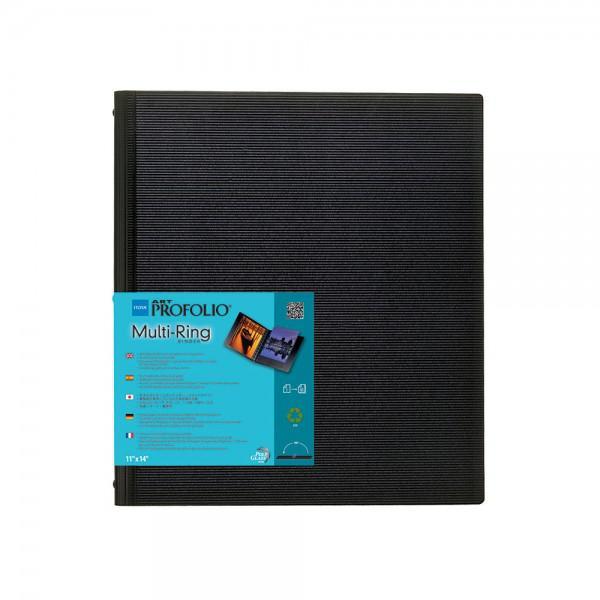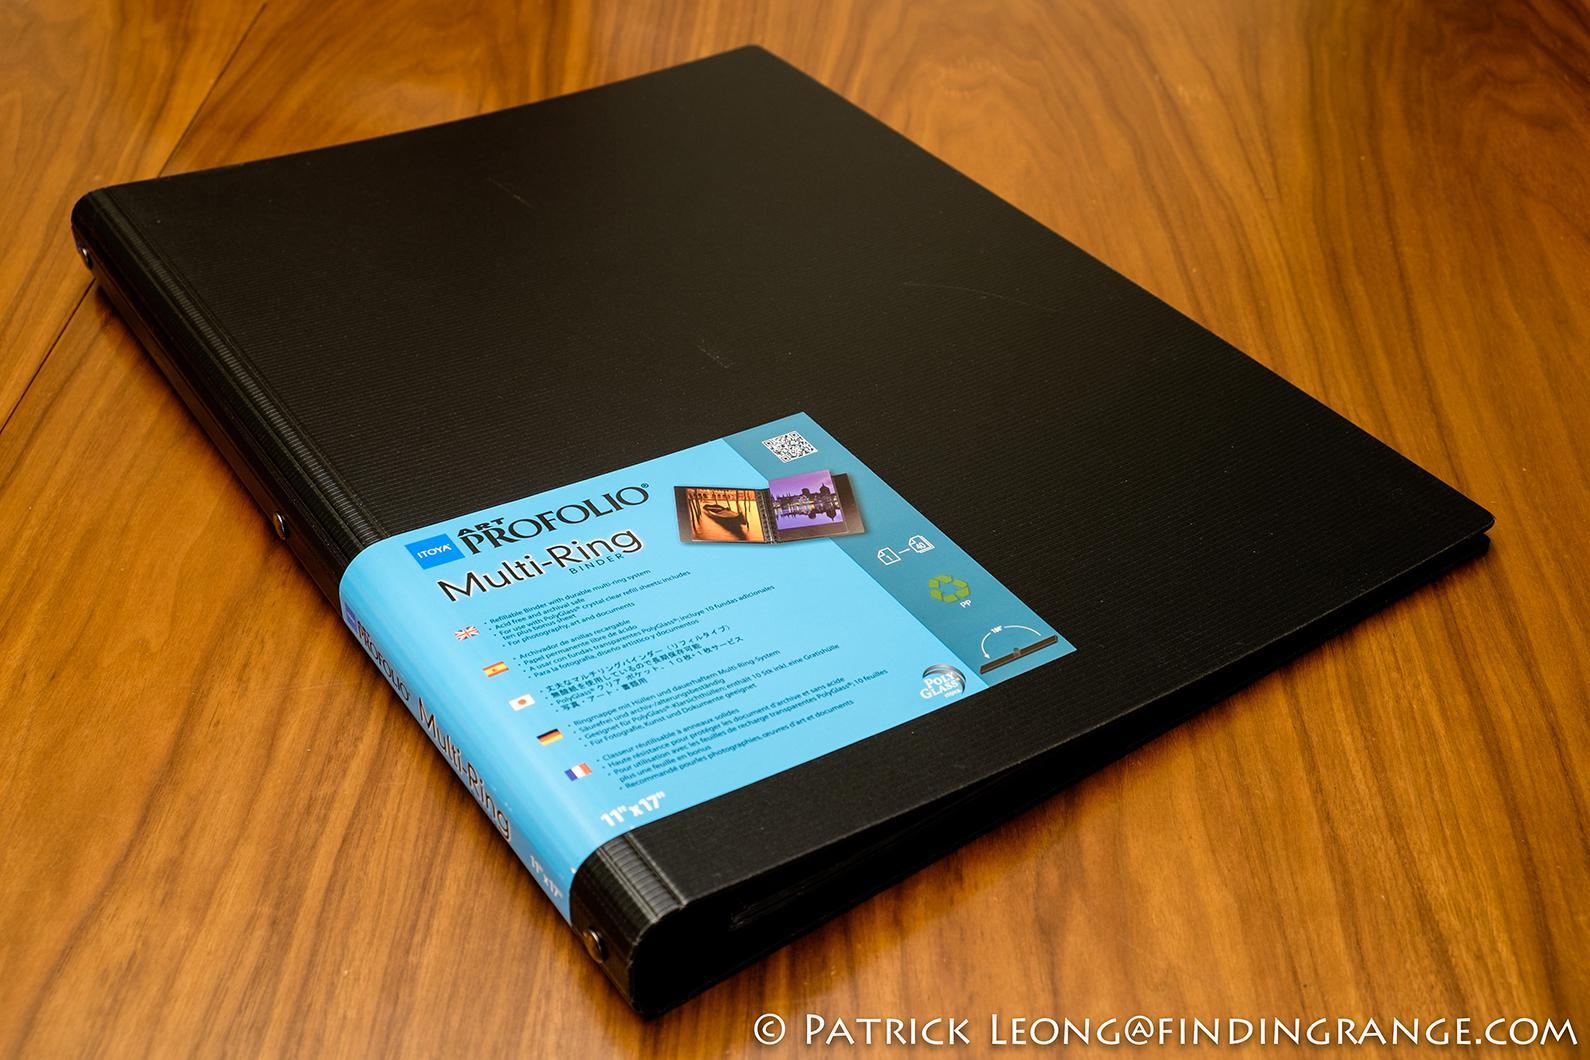The first image is the image on the left, the second image is the image on the right. Given the left and right images, does the statement "Two solid black notebook binders with center rings are in the open position." hold true? Answer yes or no. No. The first image is the image on the left, the second image is the image on the right. Evaluate the accuracy of this statement regarding the images: "At least one image shows one closed black binder with a colored label on the front.". Is it true? Answer yes or no. Yes. 